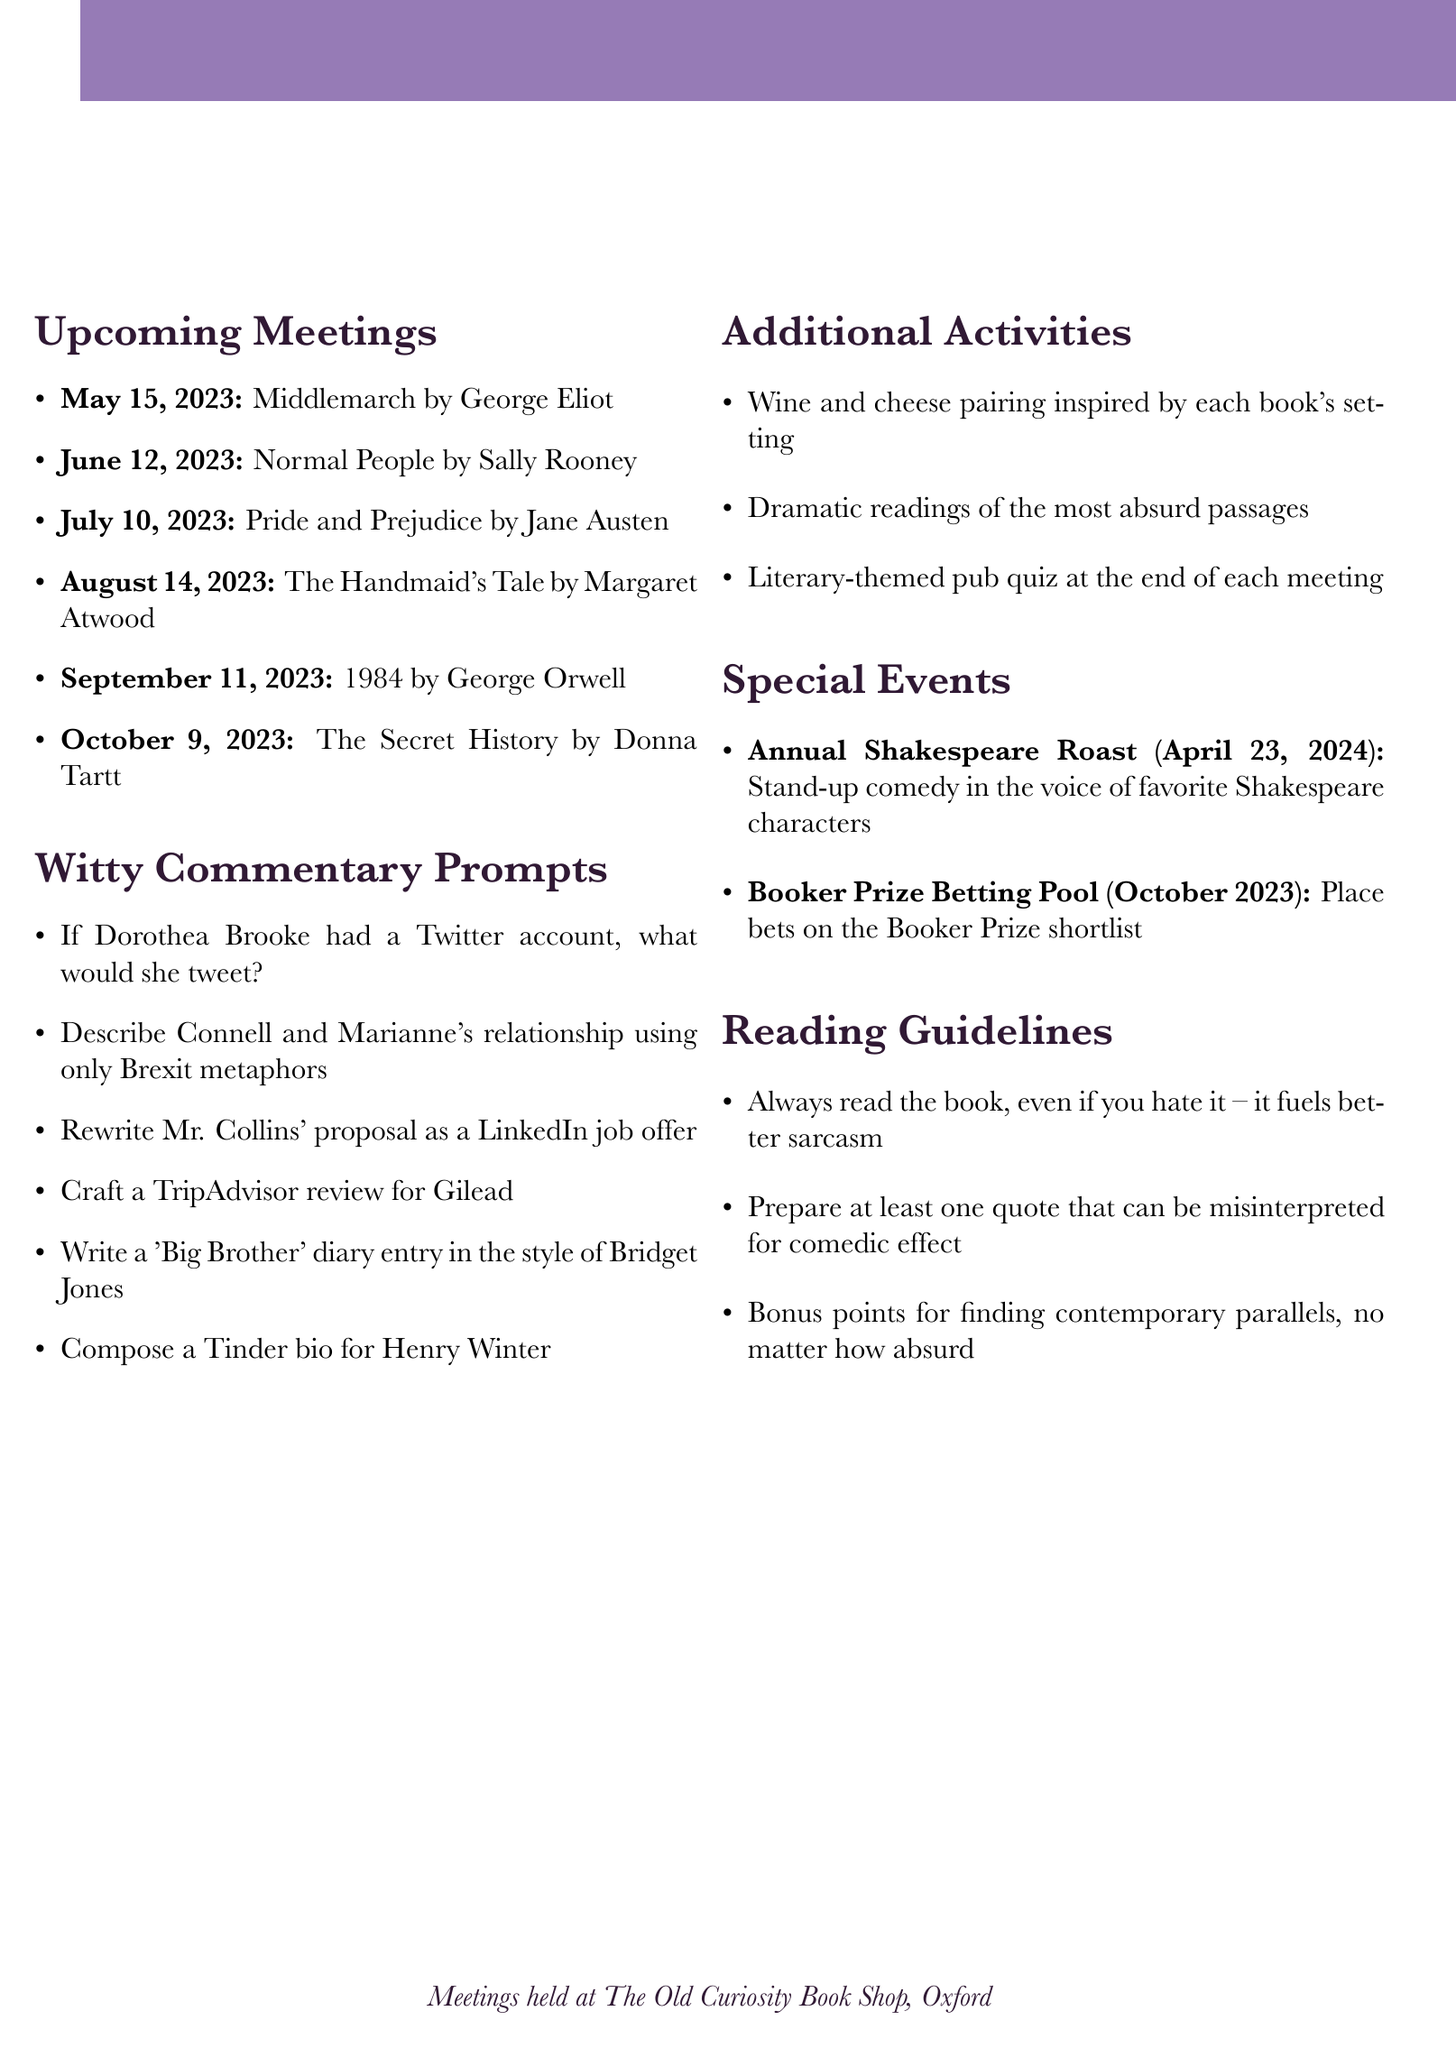What is the name of the book club? The document clearly states the book club's name at the beginning.
Answer: The Witty Wordsmiths How often does the book club meet? The meeting frequency is explicitly mentioned in the document.
Answer: Monthly Where is the book club located? The document provides the location of the meetings that is specified under meeting location.
Answer: The Old Curiosity Book Shop, Oxford When is the Annual Shakespeare Roast scheduled? The event date is listed under special events in the document.
Answer: April 23, 2024 What book is discussed in June 2023? The schedule includes the titles for each month, making it easy to find this information.
Answer: Normal People by Sally Rooney What witty commentary prompt involves Brexit? The witty commentary prompts section includes this specific prompt.
Answer: Describe Connell and Marianne's relationship using only Brexit metaphors How many books are scheduled for discussion before October 2023? The schedule lists the books up to October, enabling a straightforward counting of the titles.
Answer: Six What are members required to always do with the book? Reading guidelines provide clear expectations for members in relation to the books.
Answer: Always read the book, even if you hate it What is the voting process for book selection? The document describes how the book selection process works.
Answer: Democratic voting with veto power granted to the member with the wittiest reason for objection 